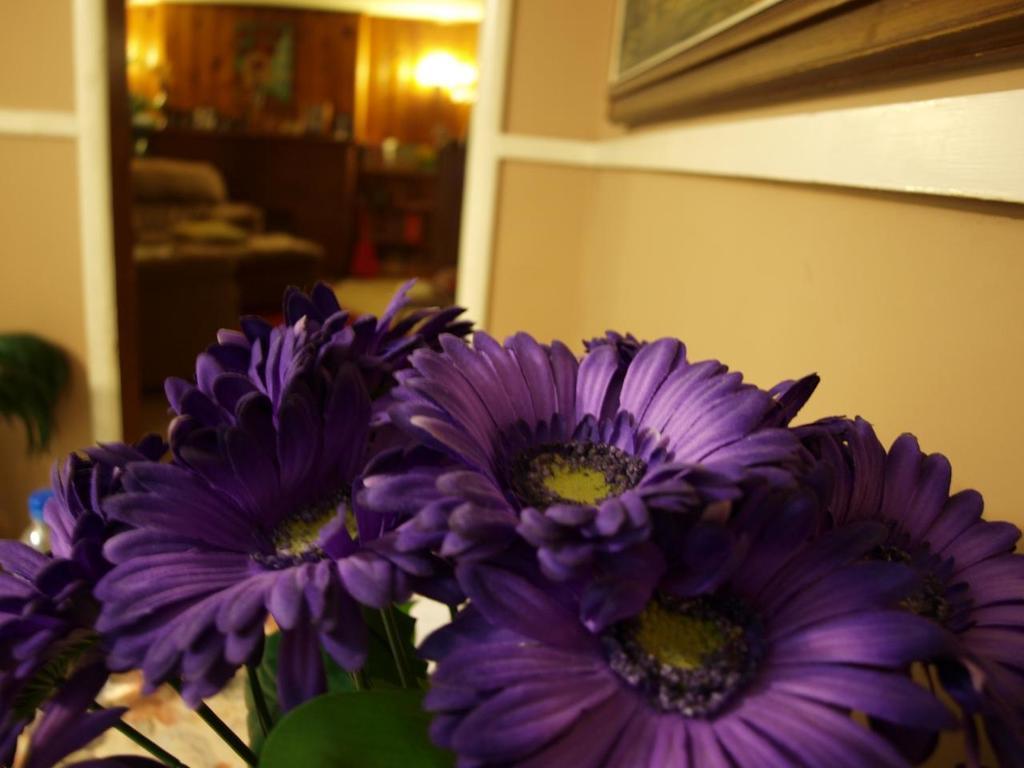Could you give a brief overview of what you see in this image? In the center of the image we can see green color objects and flowers, which are in violet and yellow color. In the background there is a wall, water bottle, one black color object, tables, photo frames, lights and a few other objects. 